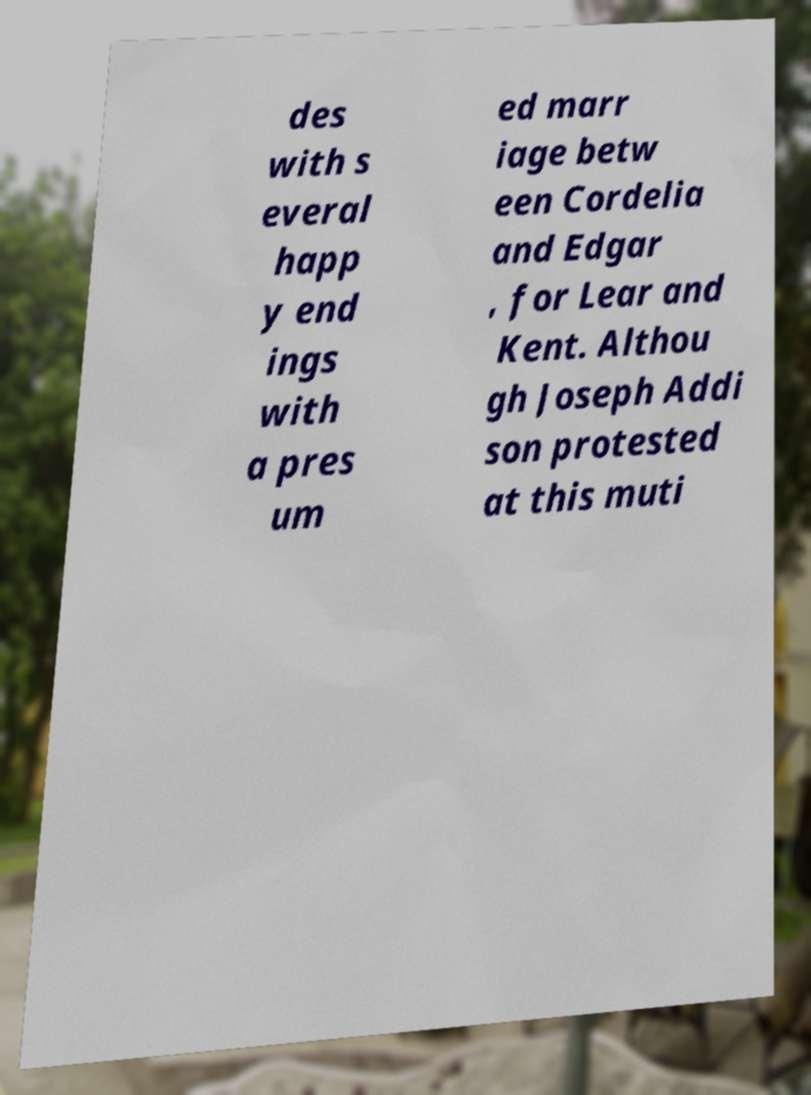Please identify and transcribe the text found in this image. des with s everal happ y end ings with a pres um ed marr iage betw een Cordelia and Edgar , for Lear and Kent. Althou gh Joseph Addi son protested at this muti 